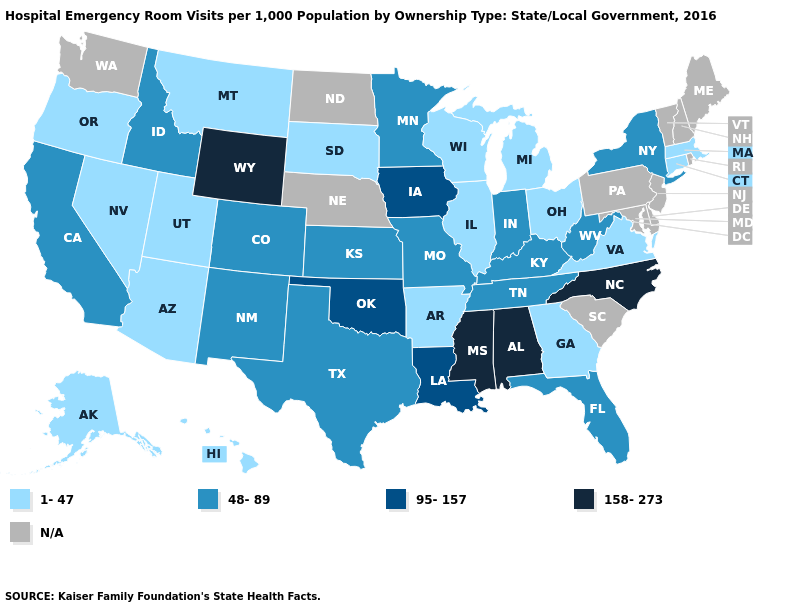What is the value of Rhode Island?
Be succinct. N/A. Among the states that border Utah , which have the highest value?
Write a very short answer. Wyoming. Name the states that have a value in the range 158-273?
Short answer required. Alabama, Mississippi, North Carolina, Wyoming. What is the value of North Dakota?
Quick response, please. N/A. How many symbols are there in the legend?
Be succinct. 5. What is the highest value in states that border Colorado?
Give a very brief answer. 158-273. What is the value of Maine?
Keep it brief. N/A. What is the lowest value in the USA?
Keep it brief. 1-47. Which states have the highest value in the USA?
Write a very short answer. Alabama, Mississippi, North Carolina, Wyoming. What is the lowest value in the USA?
Be succinct. 1-47. Does Alabama have the highest value in the USA?
Concise answer only. Yes. What is the lowest value in the Northeast?
Be succinct. 1-47. Which states have the lowest value in the USA?
Short answer required. Alaska, Arizona, Arkansas, Connecticut, Georgia, Hawaii, Illinois, Massachusetts, Michigan, Montana, Nevada, Ohio, Oregon, South Dakota, Utah, Virginia, Wisconsin. Among the states that border Nebraska , which have the lowest value?
Answer briefly. South Dakota. What is the lowest value in states that border Colorado?
Keep it brief. 1-47. 